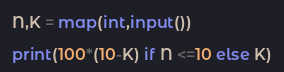<code> <loc_0><loc_0><loc_500><loc_500><_Python_>N,K = map(int,input())

print(100*(10-K) if N <=10 else K)</code> 